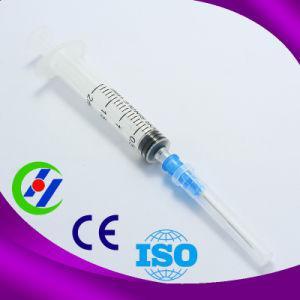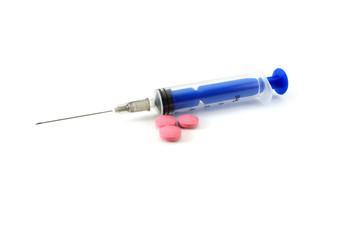The first image is the image on the left, the second image is the image on the right. Given the left and right images, does the statement "Atleast one of the images has 4 needles" hold true? Answer yes or no. No. The first image is the image on the left, the second image is the image on the right. Evaluate the accuracy of this statement regarding the images: "One of the images contains four syringes that appear to be red in color or fill.". Is it true? Answer yes or no. No. 